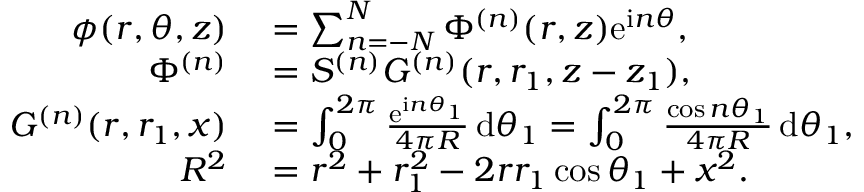Convert formula to latex. <formula><loc_0><loc_0><loc_500><loc_500>\begin{array} { r l } { \phi ( r , \theta , z ) } & = \sum _ { n = - N } ^ { N } \Phi ^ { ( n ) } ( r , z ) e ^ { i n \theta } , } \\ { \Phi ^ { ( n ) } } & = S ^ { ( n ) } G ^ { ( n ) } ( r , r _ { 1 } , z - z _ { 1 } ) , } \\ { G ^ { ( n ) } ( r , r _ { 1 } , x ) } & = \int _ { 0 } ^ { 2 \pi } \frac { e ^ { i n \theta _ { 1 } } } { 4 \pi R } \, d \theta _ { 1 } = \int _ { 0 } ^ { 2 \pi } \frac { \cos n \theta _ { 1 } } { 4 \pi R } \, d \theta _ { 1 } , } \\ { R ^ { 2 } } & = r ^ { 2 } + r _ { 1 } ^ { 2 } - 2 r r _ { 1 } \cos \theta _ { 1 } + x ^ { 2 } . } \end{array}</formula> 